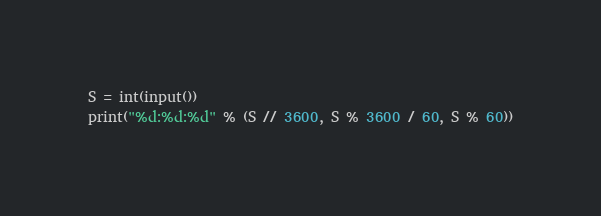Convert code to text. <code><loc_0><loc_0><loc_500><loc_500><_Python_>S = int(input())
print("%d:%d:%d" % (S // 3600, S % 3600 / 60, S % 60))</code> 